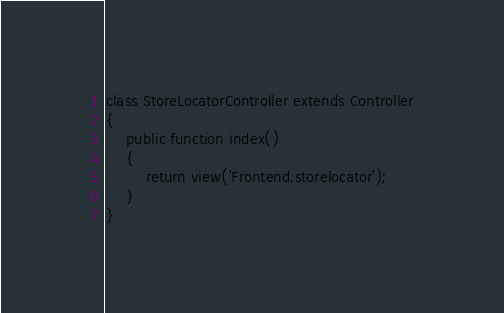Convert code to text. <code><loc_0><loc_0><loc_500><loc_500><_PHP_>class StoreLocatorController extends Controller
{
    public function index()
    {
        return view('Frontend.storelocator');
    }
}
</code> 